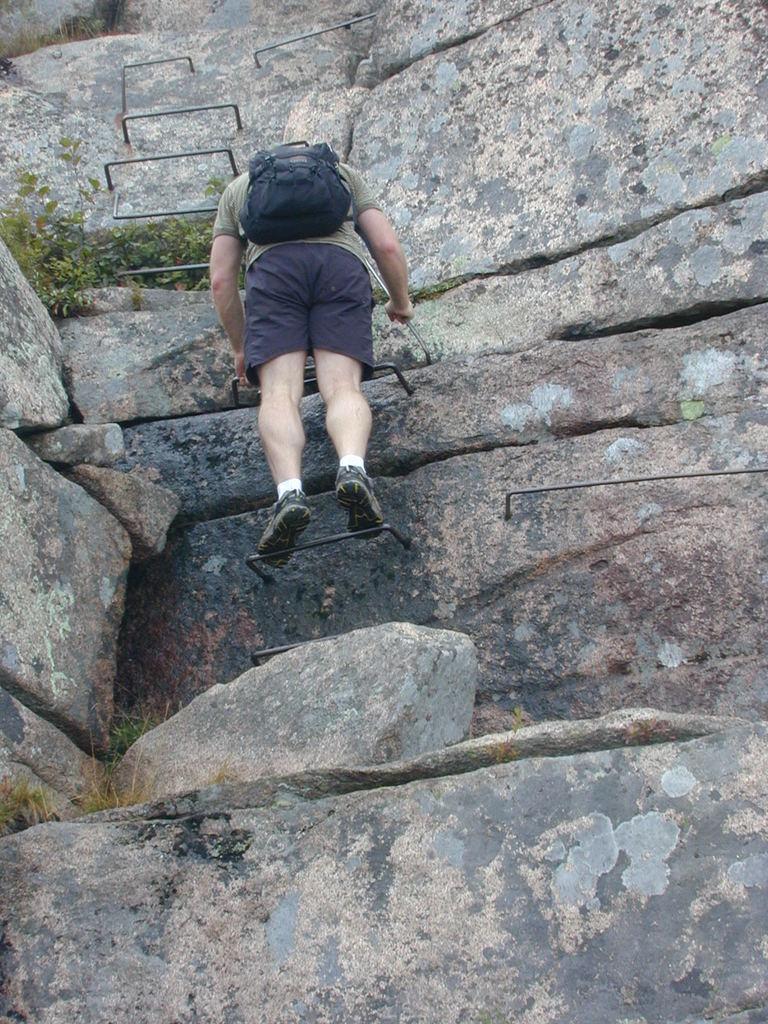Can you describe this image briefly? In this picture there is a hill or a mountain. In the center of the picture there is a person climbing with the help of iron object. On the left there are plants. 